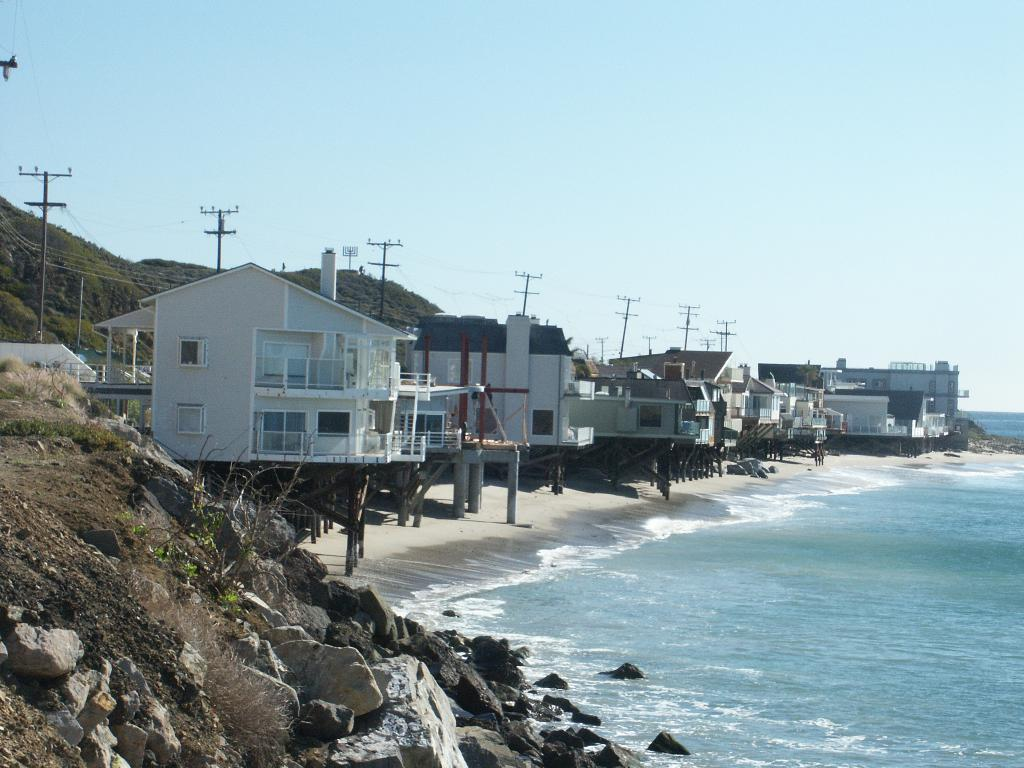What is visible in the image? There is water visible in the image. What can be seen in the background of the image? There are buildings with white and brown colors in the background. What structures are present in the image? There are electric poles in the image. What type of vegetation is present in the image? There are trees with green color in the image. What is the color of the sky in the image? The sky is blue and white in color. How many bulbs are hanging from the trees in the image? There are no bulbs present in the image; it features trees with green leaves. What is the desire of the property in the image? There is no property or desire mentioned in the image; it only shows natural elements like water, trees, and sky. 